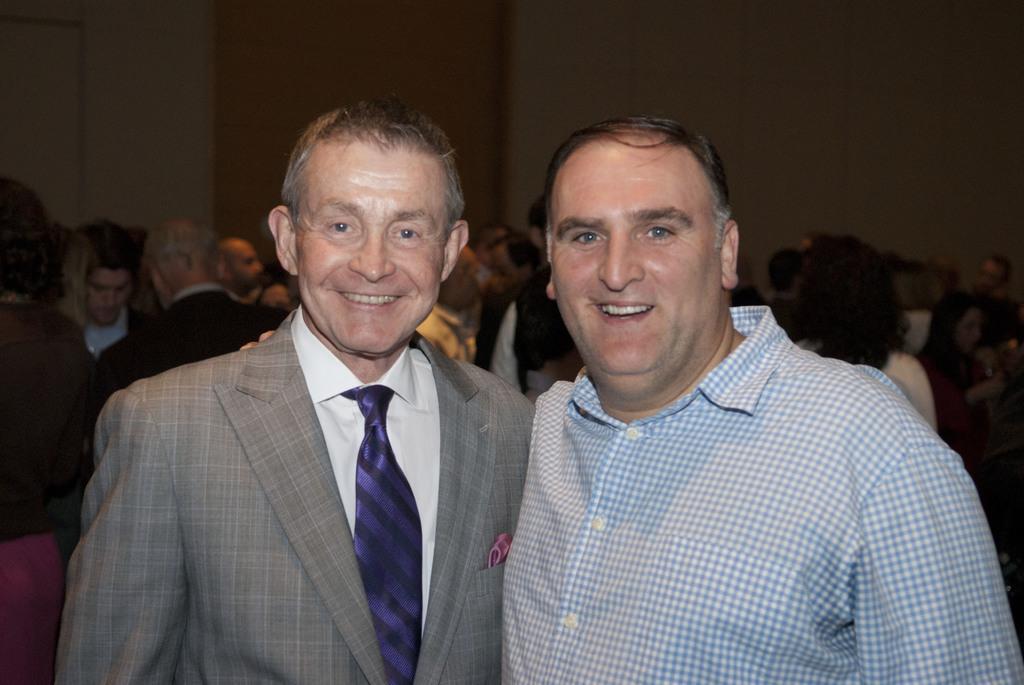Describe this image in one or two sentences. In this image, we can see persons wearing clothes. There is a wall at the top of the image. 